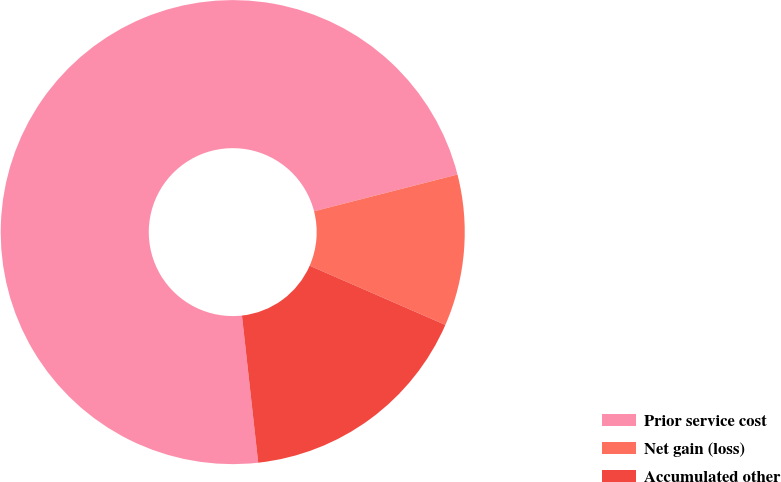<chart> <loc_0><loc_0><loc_500><loc_500><pie_chart><fcel>Prior service cost<fcel>Net gain (loss)<fcel>Accumulated other<nl><fcel>72.76%<fcel>10.54%<fcel>16.7%<nl></chart> 